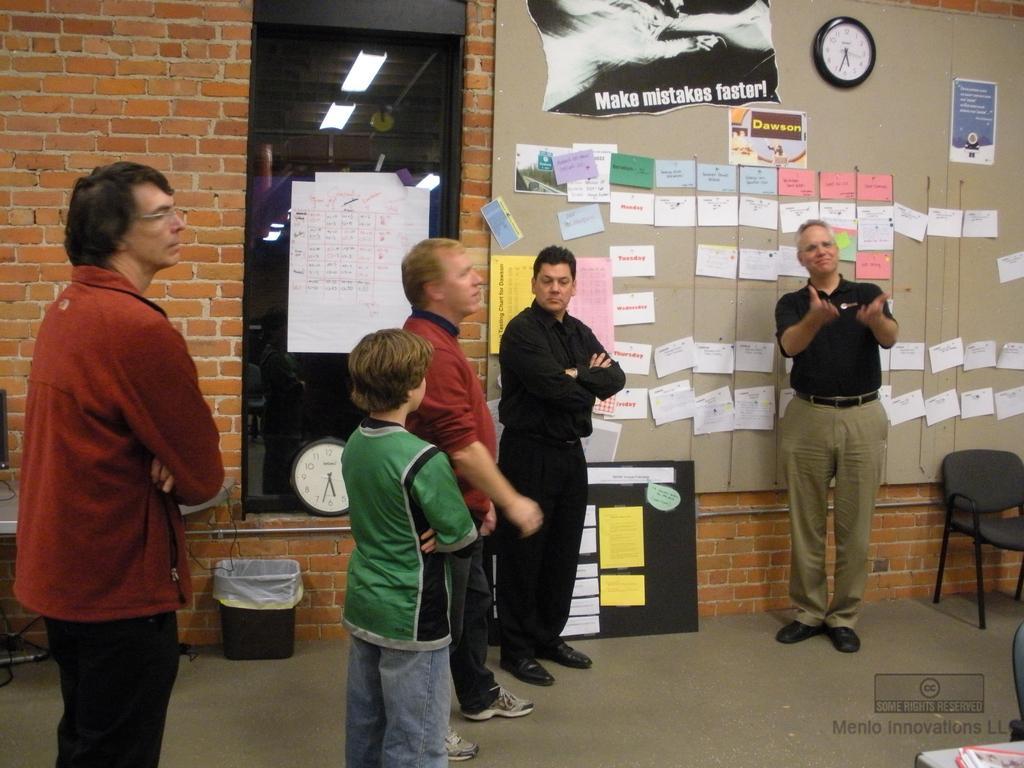Describe this image in one or two sentences. in the picture there are many people in which there are four men and one boy one man is talking,on the wall there are many papers attached there is a clock on the wall. 